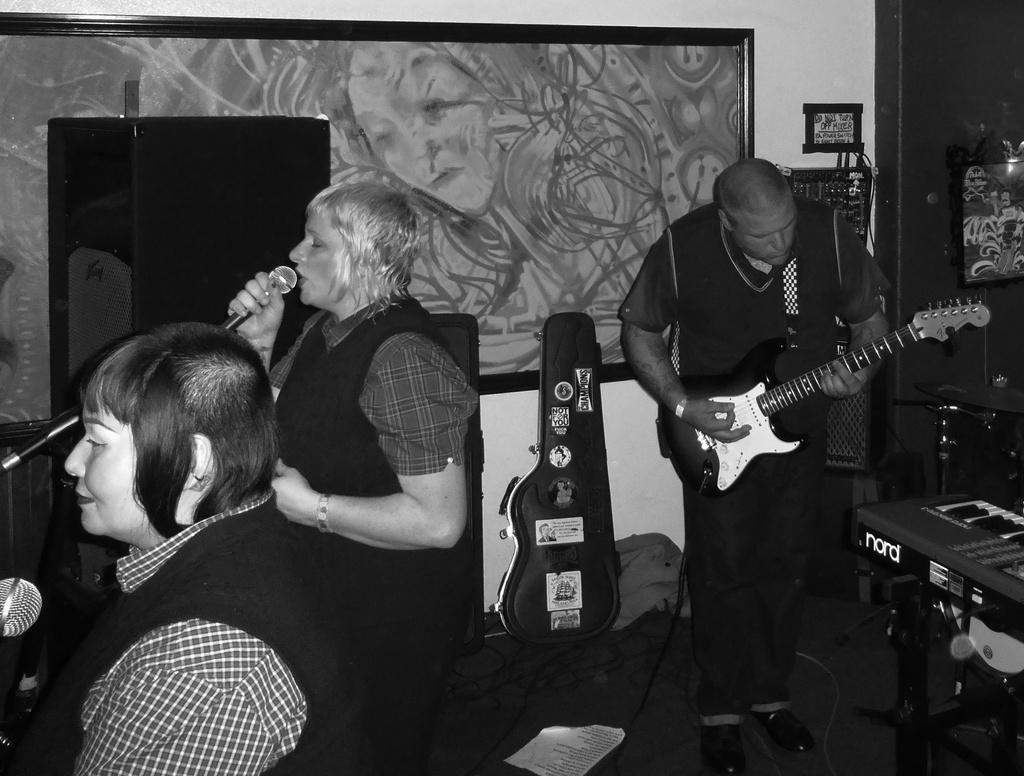How many people are in the image? There are three people in the image: two women and one man. What are the women doing in the image? The women are singing and using a microphone. What is the man doing in the image? The man is playing a guitar. What flavor of crayon is the man using to play the guitar in the image? There are no crayons present in the image, and the man is playing a guitar, not using a crayon. 